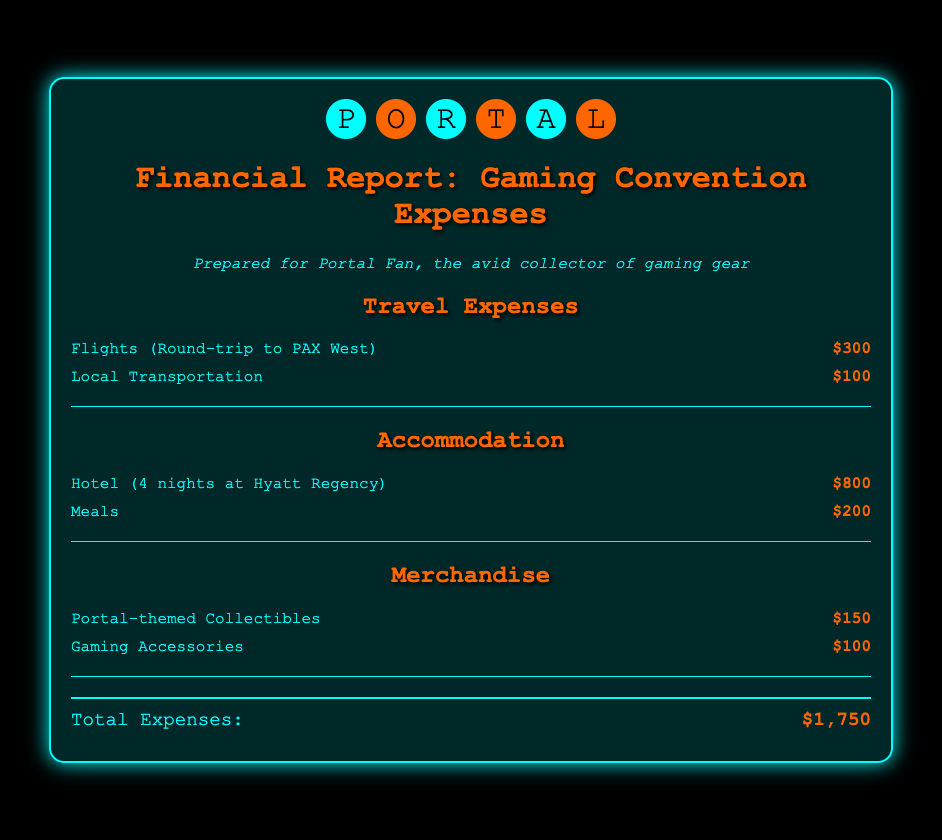What are the total travel expenses? The total travel expenses are derived from the flights and local transportation costs, which sum up to $300 + $100.
Answer: $400 What is the cost of hotel accommodation? The cost for the hotel accommodation over 4 nights is specified in the report.
Answer: $800 How much was spent on meals? The meals cost is explicitly mentioned in the accommodation section of the report.
Answer: $200 What is the total spent on Portal-themed collectibles? The document lists the cost of Portal-themed collectibles under the merchandise section.
Answer: $150 What are the total merchandise expenses? The total merchandise expenses are calculated from the costs of Portal-themed collectibles and gaming accessories.
Answer: $250 What is the overall total expense for the convention? The overall total expense is provided at the end of the report and includes all expenses summed up.
Answer: $1,750 How many nights was the hotel booked for? The report states the number of nights booked for the hotel accommodation.
Answer: 4 What is the cost of local transportation? The document specifies the local transportation cost in the travel expenses section.
Answer: $100 What category does "Gaming Accessories" fall under? The "Gaming Accessories" item is reported under the merchandise section of expenses.
Answer: Merchandise 